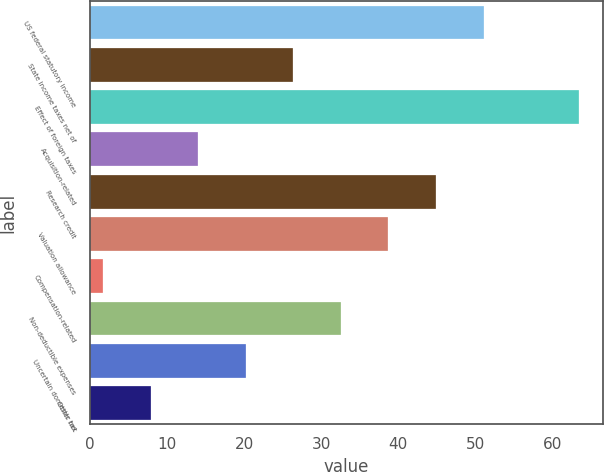Convert chart. <chart><loc_0><loc_0><loc_500><loc_500><bar_chart><fcel>US federal statutory income<fcel>State income taxes net of<fcel>Effect of foreign taxes<fcel>Acquisition-related<fcel>Research credit<fcel>Valuation allowance<fcel>Compensation-related<fcel>Non-deductible expenses<fcel>Uncertain domestic tax<fcel>Other net<nl><fcel>51.06<fcel>26.38<fcel>63.4<fcel>14.04<fcel>44.89<fcel>38.72<fcel>1.7<fcel>32.55<fcel>20.21<fcel>7.87<nl></chart> 